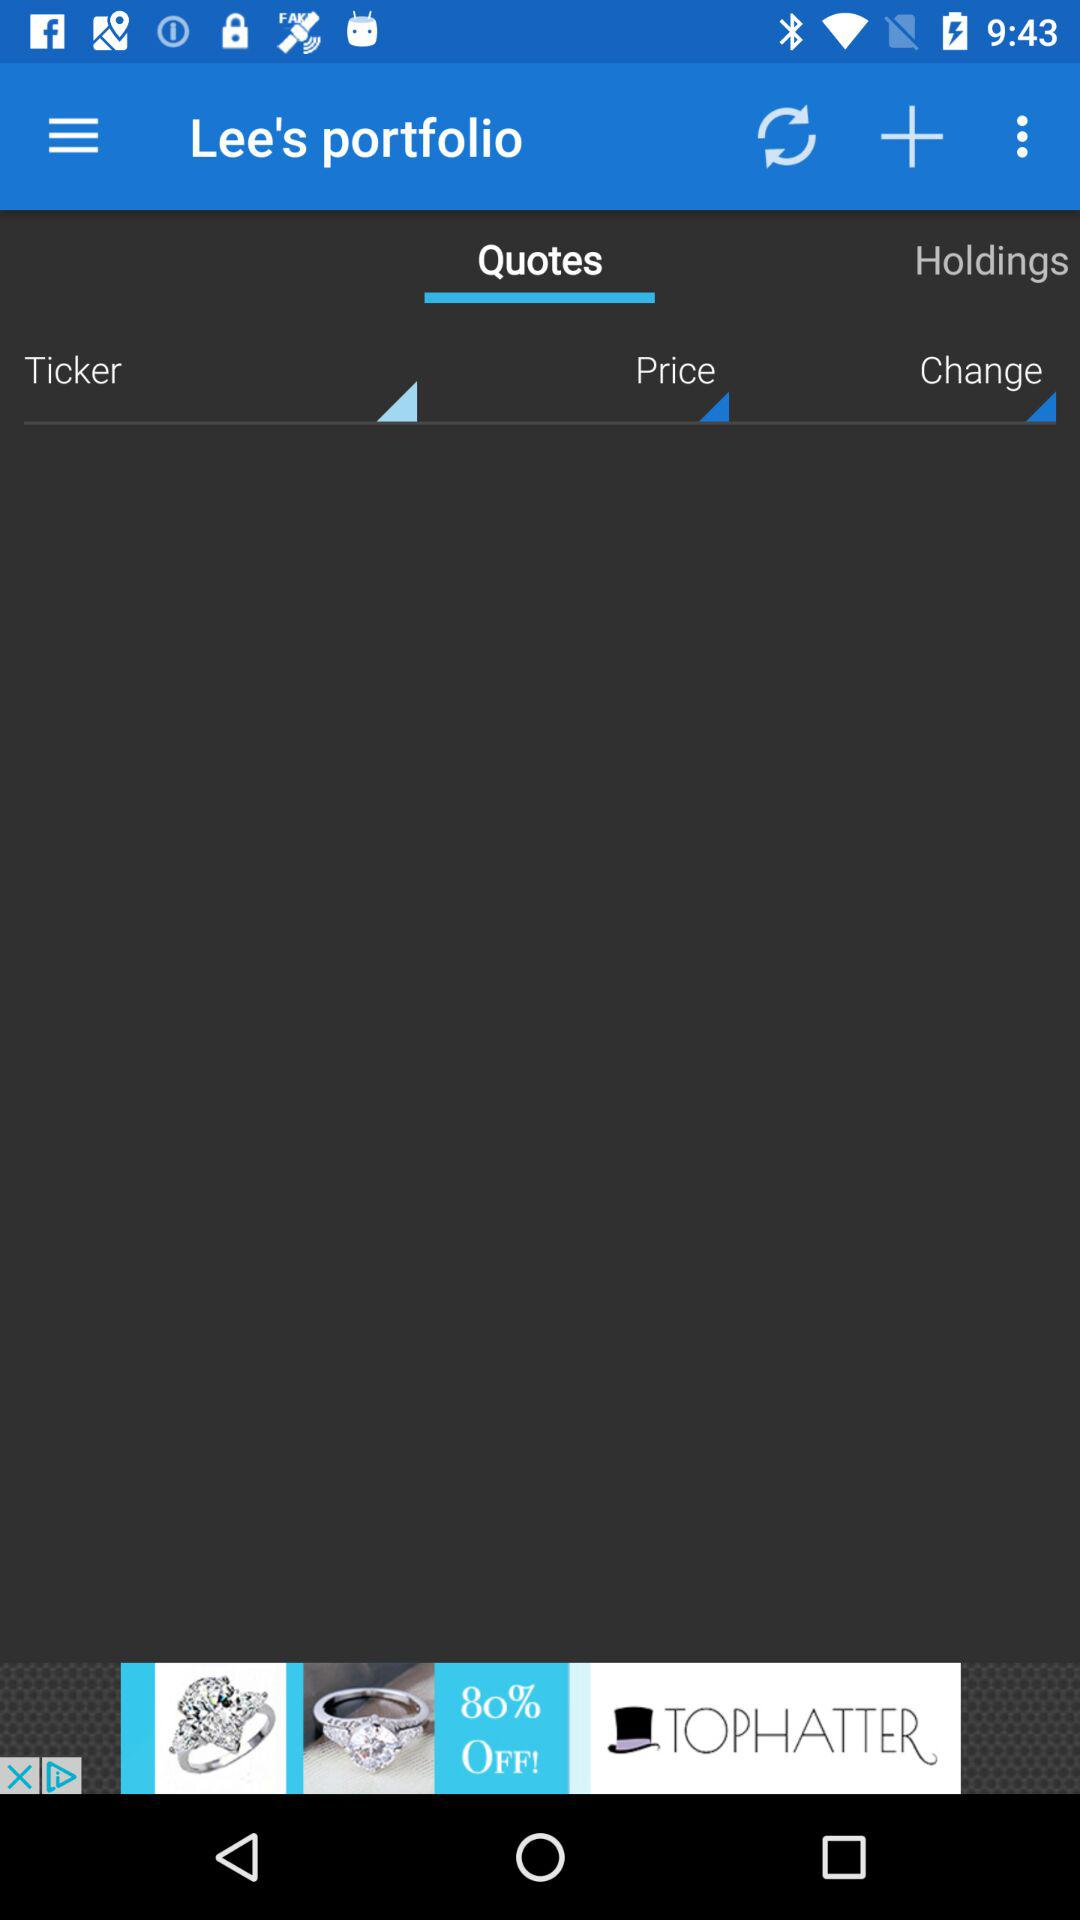Whose portfolio is this? This is Lee's portfolio. 